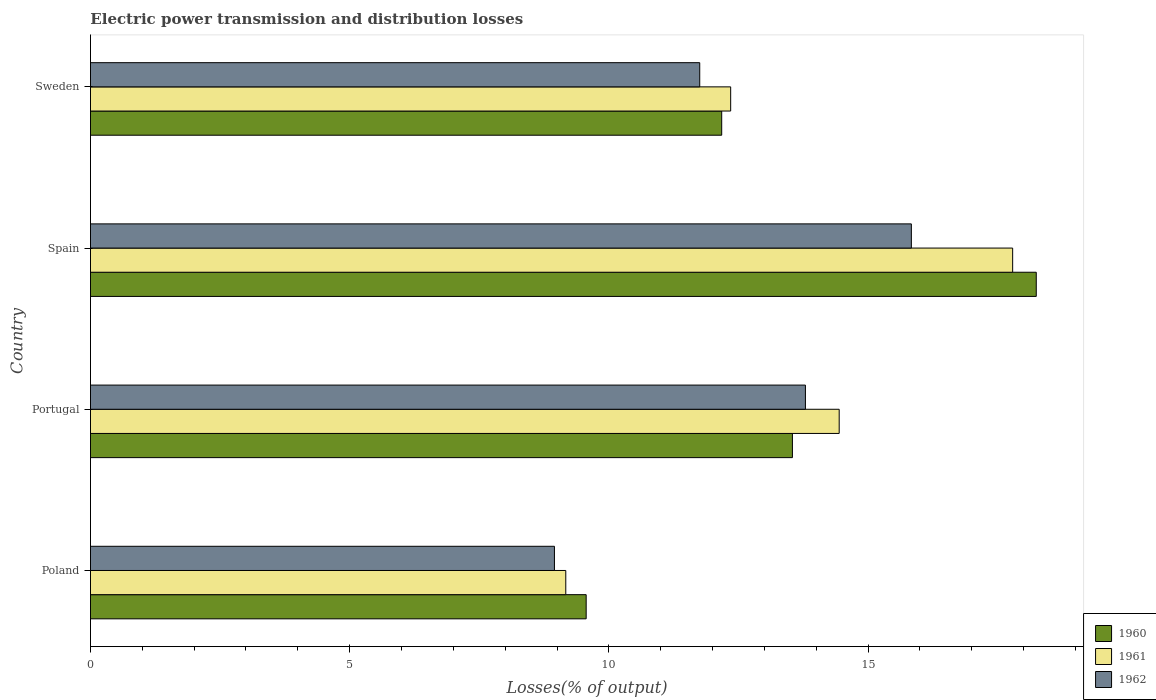Are the number of bars per tick equal to the number of legend labels?
Provide a succinct answer. Yes. How many bars are there on the 2nd tick from the top?
Offer a very short reply. 3. How many bars are there on the 2nd tick from the bottom?
Make the answer very short. 3. What is the electric power transmission and distribution losses in 1961 in Sweden?
Your answer should be very brief. 12.35. Across all countries, what is the maximum electric power transmission and distribution losses in 1960?
Ensure brevity in your answer.  18.24. Across all countries, what is the minimum electric power transmission and distribution losses in 1962?
Give a very brief answer. 8.95. In which country was the electric power transmission and distribution losses in 1960 minimum?
Give a very brief answer. Poland. What is the total electric power transmission and distribution losses in 1960 in the graph?
Make the answer very short. 53.52. What is the difference between the electric power transmission and distribution losses in 1961 in Poland and that in Spain?
Offer a very short reply. -8.62. What is the difference between the electric power transmission and distribution losses in 1961 in Poland and the electric power transmission and distribution losses in 1960 in Spain?
Your response must be concise. -9.08. What is the average electric power transmission and distribution losses in 1962 per country?
Your response must be concise. 12.58. What is the difference between the electric power transmission and distribution losses in 1960 and electric power transmission and distribution losses in 1961 in Spain?
Your response must be concise. 0.46. What is the ratio of the electric power transmission and distribution losses in 1962 in Poland to that in Portugal?
Offer a very short reply. 0.65. Is the electric power transmission and distribution losses in 1962 in Poland less than that in Spain?
Give a very brief answer. Yes. What is the difference between the highest and the second highest electric power transmission and distribution losses in 1962?
Provide a short and direct response. 2.04. What is the difference between the highest and the lowest electric power transmission and distribution losses in 1961?
Ensure brevity in your answer.  8.62. In how many countries, is the electric power transmission and distribution losses in 1962 greater than the average electric power transmission and distribution losses in 1962 taken over all countries?
Keep it short and to the point. 2. What does the 3rd bar from the top in Portugal represents?
Give a very brief answer. 1960. What does the 1st bar from the bottom in Sweden represents?
Your answer should be very brief. 1960. Is it the case that in every country, the sum of the electric power transmission and distribution losses in 1962 and electric power transmission and distribution losses in 1961 is greater than the electric power transmission and distribution losses in 1960?
Your answer should be very brief. Yes. How many bars are there?
Provide a succinct answer. 12. What is the difference between two consecutive major ticks on the X-axis?
Offer a very short reply. 5. How are the legend labels stacked?
Keep it short and to the point. Vertical. What is the title of the graph?
Ensure brevity in your answer.  Electric power transmission and distribution losses. What is the label or title of the X-axis?
Your response must be concise. Losses(% of output). What is the Losses(% of output) in 1960 in Poland?
Offer a terse response. 9.56. What is the Losses(% of output) of 1961 in Poland?
Your answer should be very brief. 9.17. What is the Losses(% of output) in 1962 in Poland?
Give a very brief answer. 8.95. What is the Losses(% of output) of 1960 in Portugal?
Offer a very short reply. 13.54. What is the Losses(% of output) of 1961 in Portugal?
Provide a short and direct response. 14.44. What is the Losses(% of output) in 1962 in Portugal?
Make the answer very short. 13.79. What is the Losses(% of output) of 1960 in Spain?
Your answer should be compact. 18.24. What is the Losses(% of output) of 1961 in Spain?
Your answer should be very brief. 17.79. What is the Losses(% of output) in 1962 in Spain?
Provide a succinct answer. 15.83. What is the Losses(% of output) in 1960 in Sweden?
Make the answer very short. 12.18. What is the Losses(% of output) in 1961 in Sweden?
Your answer should be compact. 12.35. What is the Losses(% of output) in 1962 in Sweden?
Give a very brief answer. 11.75. Across all countries, what is the maximum Losses(% of output) in 1960?
Make the answer very short. 18.24. Across all countries, what is the maximum Losses(% of output) of 1961?
Make the answer very short. 17.79. Across all countries, what is the maximum Losses(% of output) in 1962?
Ensure brevity in your answer.  15.83. Across all countries, what is the minimum Losses(% of output) in 1960?
Provide a short and direct response. 9.56. Across all countries, what is the minimum Losses(% of output) in 1961?
Your answer should be very brief. 9.17. Across all countries, what is the minimum Losses(% of output) of 1962?
Your response must be concise. 8.95. What is the total Losses(% of output) of 1960 in the graph?
Provide a succinct answer. 53.52. What is the total Losses(% of output) in 1961 in the graph?
Your response must be concise. 53.75. What is the total Losses(% of output) of 1962 in the graph?
Provide a succinct answer. 50.33. What is the difference between the Losses(% of output) in 1960 in Poland and that in Portugal?
Offer a terse response. -3.98. What is the difference between the Losses(% of output) of 1961 in Poland and that in Portugal?
Ensure brevity in your answer.  -5.27. What is the difference between the Losses(% of output) in 1962 in Poland and that in Portugal?
Provide a succinct answer. -4.84. What is the difference between the Losses(% of output) of 1960 in Poland and that in Spain?
Ensure brevity in your answer.  -8.68. What is the difference between the Losses(% of output) in 1961 in Poland and that in Spain?
Your answer should be compact. -8.62. What is the difference between the Losses(% of output) of 1962 in Poland and that in Spain?
Offer a very short reply. -6.89. What is the difference between the Losses(% of output) in 1960 in Poland and that in Sweden?
Provide a short and direct response. -2.61. What is the difference between the Losses(% of output) of 1961 in Poland and that in Sweden?
Ensure brevity in your answer.  -3.18. What is the difference between the Losses(% of output) of 1962 in Poland and that in Sweden?
Offer a terse response. -2.8. What is the difference between the Losses(% of output) in 1960 in Portugal and that in Spain?
Ensure brevity in your answer.  -4.7. What is the difference between the Losses(% of output) in 1961 in Portugal and that in Spain?
Keep it short and to the point. -3.35. What is the difference between the Losses(% of output) of 1962 in Portugal and that in Spain?
Provide a succinct answer. -2.04. What is the difference between the Losses(% of output) of 1960 in Portugal and that in Sweden?
Your answer should be very brief. 1.36. What is the difference between the Losses(% of output) of 1961 in Portugal and that in Sweden?
Give a very brief answer. 2.09. What is the difference between the Losses(% of output) in 1962 in Portugal and that in Sweden?
Your answer should be compact. 2.04. What is the difference between the Losses(% of output) in 1960 in Spain and that in Sweden?
Offer a very short reply. 6.07. What is the difference between the Losses(% of output) of 1961 in Spain and that in Sweden?
Offer a very short reply. 5.44. What is the difference between the Losses(% of output) of 1962 in Spain and that in Sweden?
Your response must be concise. 4.08. What is the difference between the Losses(% of output) of 1960 in Poland and the Losses(% of output) of 1961 in Portugal?
Make the answer very short. -4.88. What is the difference between the Losses(% of output) in 1960 in Poland and the Losses(% of output) in 1962 in Portugal?
Make the answer very short. -4.23. What is the difference between the Losses(% of output) in 1961 in Poland and the Losses(% of output) in 1962 in Portugal?
Make the answer very short. -4.62. What is the difference between the Losses(% of output) in 1960 in Poland and the Losses(% of output) in 1961 in Spain?
Provide a short and direct response. -8.23. What is the difference between the Losses(% of output) of 1960 in Poland and the Losses(% of output) of 1962 in Spain?
Keep it short and to the point. -6.27. What is the difference between the Losses(% of output) in 1961 in Poland and the Losses(% of output) in 1962 in Spain?
Give a very brief answer. -6.67. What is the difference between the Losses(% of output) in 1960 in Poland and the Losses(% of output) in 1961 in Sweden?
Provide a succinct answer. -2.79. What is the difference between the Losses(% of output) in 1960 in Poland and the Losses(% of output) in 1962 in Sweden?
Give a very brief answer. -2.19. What is the difference between the Losses(% of output) in 1961 in Poland and the Losses(% of output) in 1962 in Sweden?
Provide a succinct answer. -2.58. What is the difference between the Losses(% of output) in 1960 in Portugal and the Losses(% of output) in 1961 in Spain?
Offer a terse response. -4.25. What is the difference between the Losses(% of output) in 1960 in Portugal and the Losses(% of output) in 1962 in Spain?
Your response must be concise. -2.29. What is the difference between the Losses(% of output) in 1961 in Portugal and the Losses(% of output) in 1962 in Spain?
Make the answer very short. -1.39. What is the difference between the Losses(% of output) in 1960 in Portugal and the Losses(% of output) in 1961 in Sweden?
Offer a terse response. 1.19. What is the difference between the Losses(% of output) of 1960 in Portugal and the Losses(% of output) of 1962 in Sweden?
Give a very brief answer. 1.79. What is the difference between the Losses(% of output) of 1961 in Portugal and the Losses(% of output) of 1962 in Sweden?
Make the answer very short. 2.69. What is the difference between the Losses(% of output) of 1960 in Spain and the Losses(% of output) of 1961 in Sweden?
Your answer should be very brief. 5.89. What is the difference between the Losses(% of output) of 1960 in Spain and the Losses(% of output) of 1962 in Sweden?
Your answer should be very brief. 6.49. What is the difference between the Losses(% of output) in 1961 in Spain and the Losses(% of output) in 1962 in Sweden?
Ensure brevity in your answer.  6.04. What is the average Losses(% of output) in 1960 per country?
Provide a short and direct response. 13.38. What is the average Losses(% of output) of 1961 per country?
Keep it short and to the point. 13.44. What is the average Losses(% of output) of 1962 per country?
Offer a terse response. 12.58. What is the difference between the Losses(% of output) of 1960 and Losses(% of output) of 1961 in Poland?
Provide a short and direct response. 0.39. What is the difference between the Losses(% of output) in 1960 and Losses(% of output) in 1962 in Poland?
Provide a short and direct response. 0.61. What is the difference between the Losses(% of output) of 1961 and Losses(% of output) of 1962 in Poland?
Provide a succinct answer. 0.22. What is the difference between the Losses(% of output) in 1960 and Losses(% of output) in 1961 in Portugal?
Provide a succinct answer. -0.9. What is the difference between the Losses(% of output) in 1960 and Losses(% of output) in 1962 in Portugal?
Provide a short and direct response. -0.25. What is the difference between the Losses(% of output) in 1961 and Losses(% of output) in 1962 in Portugal?
Make the answer very short. 0.65. What is the difference between the Losses(% of output) in 1960 and Losses(% of output) in 1961 in Spain?
Your answer should be compact. 0.46. What is the difference between the Losses(% of output) in 1960 and Losses(% of output) in 1962 in Spain?
Ensure brevity in your answer.  2.41. What is the difference between the Losses(% of output) in 1961 and Losses(% of output) in 1962 in Spain?
Give a very brief answer. 1.95. What is the difference between the Losses(% of output) in 1960 and Losses(% of output) in 1961 in Sweden?
Ensure brevity in your answer.  -0.17. What is the difference between the Losses(% of output) of 1960 and Losses(% of output) of 1962 in Sweden?
Your answer should be very brief. 0.42. What is the difference between the Losses(% of output) of 1961 and Losses(% of output) of 1962 in Sweden?
Provide a succinct answer. 0.6. What is the ratio of the Losses(% of output) of 1960 in Poland to that in Portugal?
Ensure brevity in your answer.  0.71. What is the ratio of the Losses(% of output) of 1961 in Poland to that in Portugal?
Ensure brevity in your answer.  0.63. What is the ratio of the Losses(% of output) in 1962 in Poland to that in Portugal?
Your answer should be compact. 0.65. What is the ratio of the Losses(% of output) of 1960 in Poland to that in Spain?
Ensure brevity in your answer.  0.52. What is the ratio of the Losses(% of output) of 1961 in Poland to that in Spain?
Your response must be concise. 0.52. What is the ratio of the Losses(% of output) in 1962 in Poland to that in Spain?
Give a very brief answer. 0.57. What is the ratio of the Losses(% of output) in 1960 in Poland to that in Sweden?
Give a very brief answer. 0.79. What is the ratio of the Losses(% of output) of 1961 in Poland to that in Sweden?
Your answer should be compact. 0.74. What is the ratio of the Losses(% of output) in 1962 in Poland to that in Sweden?
Keep it short and to the point. 0.76. What is the ratio of the Losses(% of output) of 1960 in Portugal to that in Spain?
Your answer should be very brief. 0.74. What is the ratio of the Losses(% of output) in 1961 in Portugal to that in Spain?
Your response must be concise. 0.81. What is the ratio of the Losses(% of output) of 1962 in Portugal to that in Spain?
Offer a very short reply. 0.87. What is the ratio of the Losses(% of output) in 1960 in Portugal to that in Sweden?
Offer a very short reply. 1.11. What is the ratio of the Losses(% of output) of 1961 in Portugal to that in Sweden?
Your answer should be very brief. 1.17. What is the ratio of the Losses(% of output) in 1962 in Portugal to that in Sweden?
Offer a very short reply. 1.17. What is the ratio of the Losses(% of output) of 1960 in Spain to that in Sweden?
Provide a succinct answer. 1.5. What is the ratio of the Losses(% of output) in 1961 in Spain to that in Sweden?
Provide a succinct answer. 1.44. What is the ratio of the Losses(% of output) in 1962 in Spain to that in Sweden?
Make the answer very short. 1.35. What is the difference between the highest and the second highest Losses(% of output) in 1960?
Give a very brief answer. 4.7. What is the difference between the highest and the second highest Losses(% of output) in 1961?
Give a very brief answer. 3.35. What is the difference between the highest and the second highest Losses(% of output) of 1962?
Make the answer very short. 2.04. What is the difference between the highest and the lowest Losses(% of output) of 1960?
Make the answer very short. 8.68. What is the difference between the highest and the lowest Losses(% of output) of 1961?
Keep it short and to the point. 8.62. What is the difference between the highest and the lowest Losses(% of output) in 1962?
Your answer should be very brief. 6.89. 